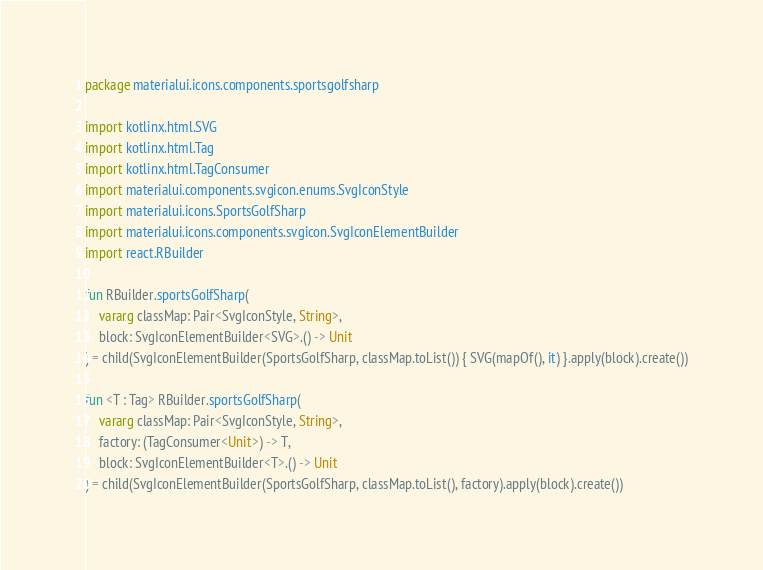<code> <loc_0><loc_0><loc_500><loc_500><_Kotlin_>package materialui.icons.components.sportsgolfsharp

import kotlinx.html.SVG
import kotlinx.html.Tag
import kotlinx.html.TagConsumer
import materialui.components.svgicon.enums.SvgIconStyle
import materialui.icons.SportsGolfSharp
import materialui.icons.components.svgicon.SvgIconElementBuilder
import react.RBuilder

fun RBuilder.sportsGolfSharp(
    vararg classMap: Pair<SvgIconStyle, String>,
    block: SvgIconElementBuilder<SVG>.() -> Unit
) = child(SvgIconElementBuilder(SportsGolfSharp, classMap.toList()) { SVG(mapOf(), it) }.apply(block).create())

fun <T : Tag> RBuilder.sportsGolfSharp(
    vararg classMap: Pair<SvgIconStyle, String>,
    factory: (TagConsumer<Unit>) -> T,
    block: SvgIconElementBuilder<T>.() -> Unit
) = child(SvgIconElementBuilder(SportsGolfSharp, classMap.toList(), factory).apply(block).create())
</code> 